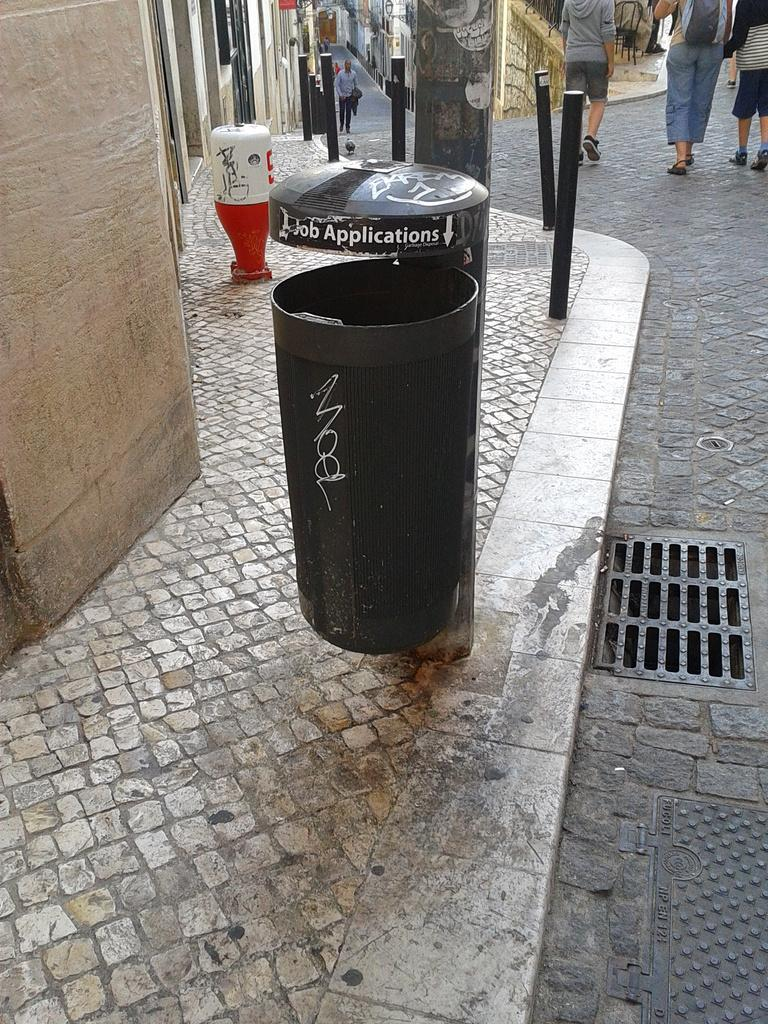<image>
Offer a succinct explanation of the picture presented. A trash can says "Job Applications" at the top. 